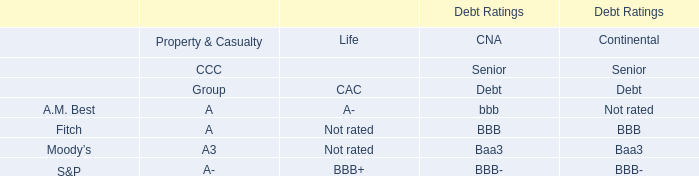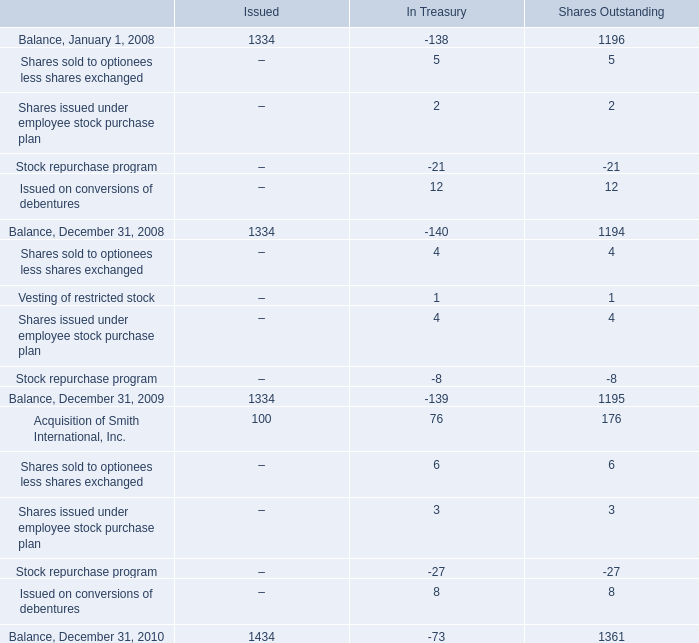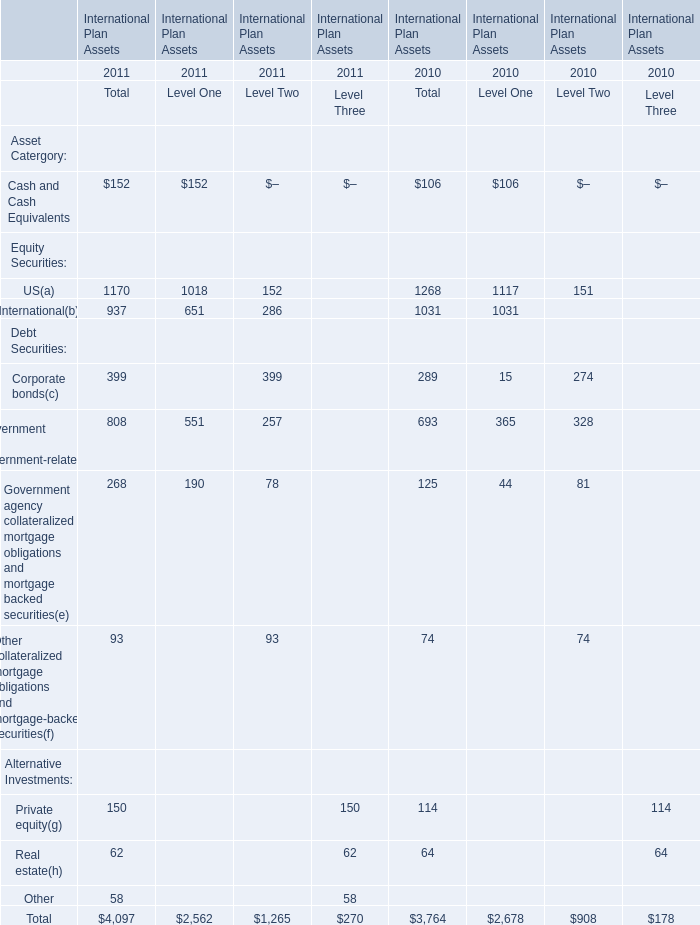What is the ratio of all elements for Total that are in the range of 600 and 1300 to the sum of elements, in2010? 
Computations: (((1268 + 1031) + 693) / 3764)
Answer: 0.7949. 